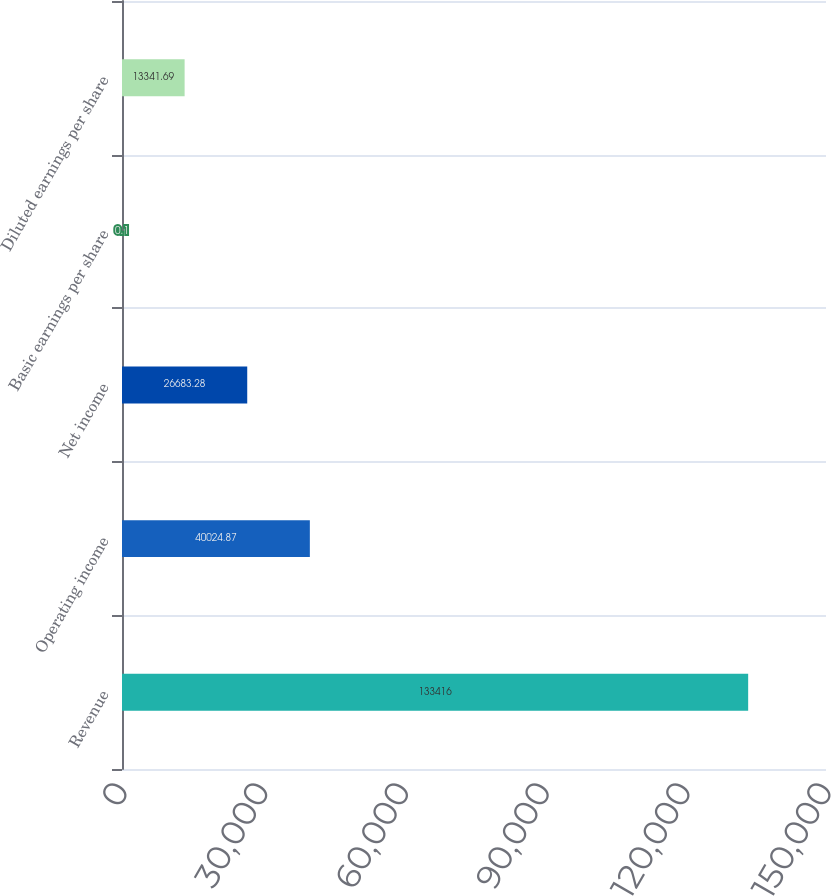Convert chart. <chart><loc_0><loc_0><loc_500><loc_500><bar_chart><fcel>Revenue<fcel>Operating income<fcel>Net income<fcel>Basic earnings per share<fcel>Diluted earnings per share<nl><fcel>133416<fcel>40024.9<fcel>26683.3<fcel>0.1<fcel>13341.7<nl></chart> 